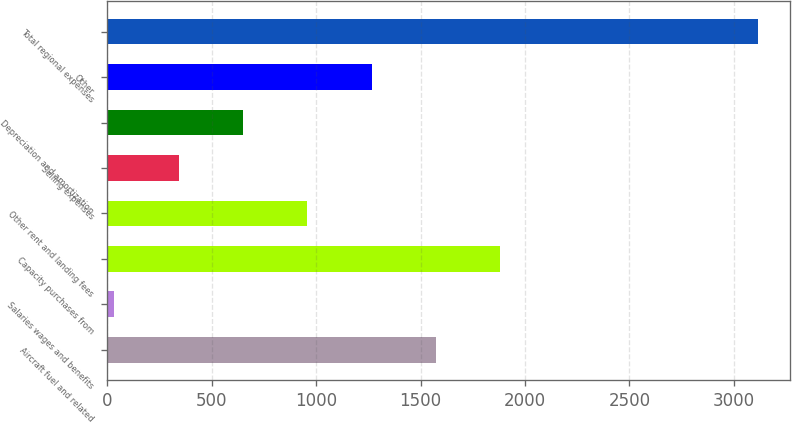Convert chart to OTSL. <chart><loc_0><loc_0><loc_500><loc_500><bar_chart><fcel>Aircraft fuel and related<fcel>Salaries wages and benefits<fcel>Capacity purchases from<fcel>Other rent and landing fees<fcel>Selling expenses<fcel>Depreciation and amortization<fcel>Other<fcel>Total regional expenses<nl><fcel>1574<fcel>35<fcel>1881.8<fcel>958.4<fcel>342.8<fcel>650.6<fcel>1266.2<fcel>3113<nl></chart> 